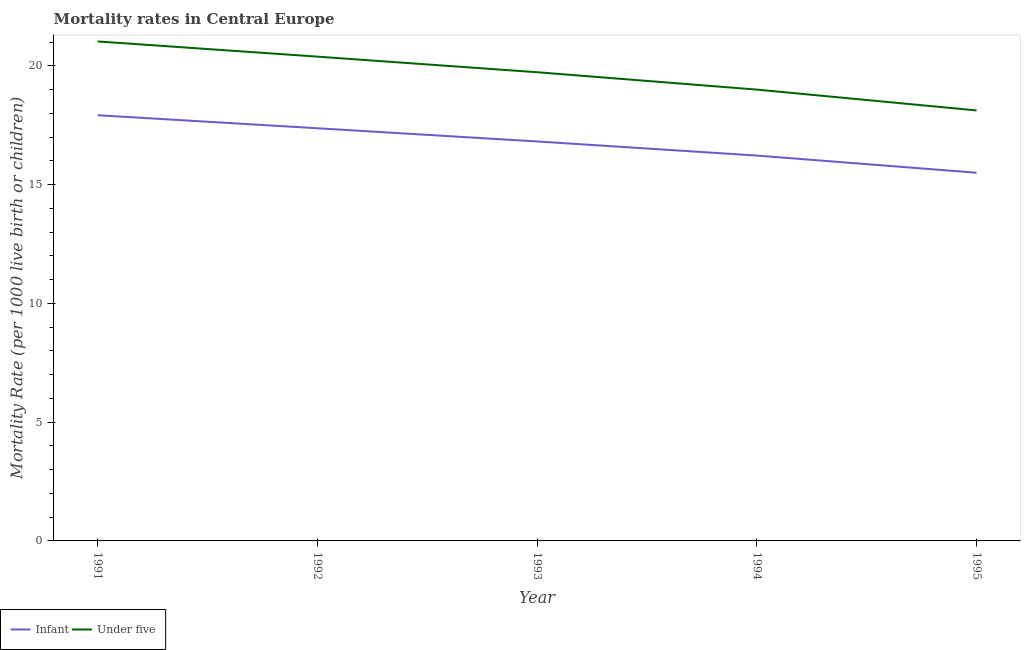Is the number of lines equal to the number of legend labels?
Provide a succinct answer. Yes. What is the infant mortality rate in 1991?
Provide a succinct answer. 17.92. Across all years, what is the maximum under-5 mortality rate?
Provide a succinct answer. 21.03. Across all years, what is the minimum under-5 mortality rate?
Ensure brevity in your answer.  18.13. In which year was the infant mortality rate minimum?
Offer a very short reply. 1995. What is the total infant mortality rate in the graph?
Your response must be concise. 83.85. What is the difference between the under-5 mortality rate in 1992 and that in 1994?
Your response must be concise. 1.39. What is the difference between the under-5 mortality rate in 1991 and the infant mortality rate in 1992?
Provide a succinct answer. 3.66. What is the average infant mortality rate per year?
Ensure brevity in your answer.  16.77. In the year 1993, what is the difference between the under-5 mortality rate and infant mortality rate?
Give a very brief answer. 2.91. What is the ratio of the infant mortality rate in 1994 to that in 1995?
Offer a very short reply. 1.05. What is the difference between the highest and the second highest under-5 mortality rate?
Make the answer very short. 0.64. What is the difference between the highest and the lowest infant mortality rate?
Make the answer very short. 2.42. Is the under-5 mortality rate strictly less than the infant mortality rate over the years?
Make the answer very short. No. How many years are there in the graph?
Offer a terse response. 5. Does the graph contain any zero values?
Keep it short and to the point. No. Does the graph contain grids?
Provide a short and direct response. No. Where does the legend appear in the graph?
Give a very brief answer. Bottom left. What is the title of the graph?
Offer a very short reply. Mortality rates in Central Europe. What is the label or title of the Y-axis?
Provide a succinct answer. Mortality Rate (per 1000 live birth or children). What is the Mortality Rate (per 1000 live birth or children) of Infant in 1991?
Provide a short and direct response. 17.92. What is the Mortality Rate (per 1000 live birth or children) of Under five in 1991?
Your response must be concise. 21.03. What is the Mortality Rate (per 1000 live birth or children) in Infant in 1992?
Provide a succinct answer. 17.38. What is the Mortality Rate (per 1000 live birth or children) of Under five in 1992?
Provide a short and direct response. 20.39. What is the Mortality Rate (per 1000 live birth or children) of Infant in 1993?
Keep it short and to the point. 16.82. What is the Mortality Rate (per 1000 live birth or children) of Under five in 1993?
Provide a short and direct response. 19.73. What is the Mortality Rate (per 1000 live birth or children) in Infant in 1994?
Give a very brief answer. 16.23. What is the Mortality Rate (per 1000 live birth or children) in Under five in 1994?
Offer a terse response. 19. What is the Mortality Rate (per 1000 live birth or children) of Infant in 1995?
Your answer should be compact. 15.5. What is the Mortality Rate (per 1000 live birth or children) in Under five in 1995?
Keep it short and to the point. 18.13. Across all years, what is the maximum Mortality Rate (per 1000 live birth or children) in Infant?
Provide a short and direct response. 17.92. Across all years, what is the maximum Mortality Rate (per 1000 live birth or children) of Under five?
Keep it short and to the point. 21.03. Across all years, what is the minimum Mortality Rate (per 1000 live birth or children) of Infant?
Give a very brief answer. 15.5. Across all years, what is the minimum Mortality Rate (per 1000 live birth or children) of Under five?
Keep it short and to the point. 18.13. What is the total Mortality Rate (per 1000 live birth or children) in Infant in the graph?
Your response must be concise. 83.85. What is the total Mortality Rate (per 1000 live birth or children) of Under five in the graph?
Make the answer very short. 98.29. What is the difference between the Mortality Rate (per 1000 live birth or children) of Infant in 1991 and that in 1992?
Your answer should be very brief. 0.55. What is the difference between the Mortality Rate (per 1000 live birth or children) of Under five in 1991 and that in 1992?
Keep it short and to the point. 0.64. What is the difference between the Mortality Rate (per 1000 live birth or children) in Infant in 1991 and that in 1993?
Provide a short and direct response. 1.1. What is the difference between the Mortality Rate (per 1000 live birth or children) of Under five in 1991 and that in 1993?
Give a very brief answer. 1.3. What is the difference between the Mortality Rate (per 1000 live birth or children) of Infant in 1991 and that in 1994?
Your answer should be compact. 1.7. What is the difference between the Mortality Rate (per 1000 live birth or children) of Under five in 1991 and that in 1994?
Provide a short and direct response. 2.03. What is the difference between the Mortality Rate (per 1000 live birth or children) in Infant in 1991 and that in 1995?
Your response must be concise. 2.42. What is the difference between the Mortality Rate (per 1000 live birth or children) in Under five in 1991 and that in 1995?
Keep it short and to the point. 2.9. What is the difference between the Mortality Rate (per 1000 live birth or children) of Infant in 1992 and that in 1993?
Make the answer very short. 0.56. What is the difference between the Mortality Rate (per 1000 live birth or children) in Under five in 1992 and that in 1993?
Provide a succinct answer. 0.66. What is the difference between the Mortality Rate (per 1000 live birth or children) in Infant in 1992 and that in 1994?
Provide a short and direct response. 1.15. What is the difference between the Mortality Rate (per 1000 live birth or children) in Under five in 1992 and that in 1994?
Make the answer very short. 1.39. What is the difference between the Mortality Rate (per 1000 live birth or children) of Infant in 1992 and that in 1995?
Keep it short and to the point. 1.87. What is the difference between the Mortality Rate (per 1000 live birth or children) in Under five in 1992 and that in 1995?
Your answer should be very brief. 2.27. What is the difference between the Mortality Rate (per 1000 live birth or children) in Infant in 1993 and that in 1994?
Your answer should be very brief. 0.59. What is the difference between the Mortality Rate (per 1000 live birth or children) of Under five in 1993 and that in 1994?
Provide a short and direct response. 0.73. What is the difference between the Mortality Rate (per 1000 live birth or children) in Infant in 1993 and that in 1995?
Your response must be concise. 1.32. What is the difference between the Mortality Rate (per 1000 live birth or children) of Under five in 1993 and that in 1995?
Ensure brevity in your answer.  1.61. What is the difference between the Mortality Rate (per 1000 live birth or children) in Infant in 1994 and that in 1995?
Your response must be concise. 0.72. What is the difference between the Mortality Rate (per 1000 live birth or children) in Under five in 1994 and that in 1995?
Provide a succinct answer. 0.88. What is the difference between the Mortality Rate (per 1000 live birth or children) of Infant in 1991 and the Mortality Rate (per 1000 live birth or children) of Under five in 1992?
Ensure brevity in your answer.  -2.47. What is the difference between the Mortality Rate (per 1000 live birth or children) of Infant in 1991 and the Mortality Rate (per 1000 live birth or children) of Under five in 1993?
Provide a short and direct response. -1.81. What is the difference between the Mortality Rate (per 1000 live birth or children) in Infant in 1991 and the Mortality Rate (per 1000 live birth or children) in Under five in 1994?
Your answer should be compact. -1.08. What is the difference between the Mortality Rate (per 1000 live birth or children) of Infant in 1991 and the Mortality Rate (per 1000 live birth or children) of Under five in 1995?
Your answer should be very brief. -0.2. What is the difference between the Mortality Rate (per 1000 live birth or children) of Infant in 1992 and the Mortality Rate (per 1000 live birth or children) of Under five in 1993?
Provide a succinct answer. -2.36. What is the difference between the Mortality Rate (per 1000 live birth or children) of Infant in 1992 and the Mortality Rate (per 1000 live birth or children) of Under five in 1994?
Make the answer very short. -1.63. What is the difference between the Mortality Rate (per 1000 live birth or children) of Infant in 1992 and the Mortality Rate (per 1000 live birth or children) of Under five in 1995?
Keep it short and to the point. -0.75. What is the difference between the Mortality Rate (per 1000 live birth or children) in Infant in 1993 and the Mortality Rate (per 1000 live birth or children) in Under five in 1994?
Your response must be concise. -2.18. What is the difference between the Mortality Rate (per 1000 live birth or children) of Infant in 1993 and the Mortality Rate (per 1000 live birth or children) of Under five in 1995?
Your answer should be compact. -1.31. What is the difference between the Mortality Rate (per 1000 live birth or children) of Infant in 1994 and the Mortality Rate (per 1000 live birth or children) of Under five in 1995?
Keep it short and to the point. -1.9. What is the average Mortality Rate (per 1000 live birth or children) of Infant per year?
Your answer should be very brief. 16.77. What is the average Mortality Rate (per 1000 live birth or children) of Under five per year?
Your answer should be very brief. 19.66. In the year 1991, what is the difference between the Mortality Rate (per 1000 live birth or children) in Infant and Mortality Rate (per 1000 live birth or children) in Under five?
Give a very brief answer. -3.11. In the year 1992, what is the difference between the Mortality Rate (per 1000 live birth or children) in Infant and Mortality Rate (per 1000 live birth or children) in Under five?
Your response must be concise. -3.02. In the year 1993, what is the difference between the Mortality Rate (per 1000 live birth or children) of Infant and Mortality Rate (per 1000 live birth or children) of Under five?
Provide a succinct answer. -2.91. In the year 1994, what is the difference between the Mortality Rate (per 1000 live birth or children) in Infant and Mortality Rate (per 1000 live birth or children) in Under five?
Provide a short and direct response. -2.78. In the year 1995, what is the difference between the Mortality Rate (per 1000 live birth or children) in Infant and Mortality Rate (per 1000 live birth or children) in Under five?
Provide a short and direct response. -2.62. What is the ratio of the Mortality Rate (per 1000 live birth or children) in Infant in 1991 to that in 1992?
Make the answer very short. 1.03. What is the ratio of the Mortality Rate (per 1000 live birth or children) in Under five in 1991 to that in 1992?
Offer a very short reply. 1.03. What is the ratio of the Mortality Rate (per 1000 live birth or children) of Infant in 1991 to that in 1993?
Your response must be concise. 1.07. What is the ratio of the Mortality Rate (per 1000 live birth or children) of Under five in 1991 to that in 1993?
Your answer should be very brief. 1.07. What is the ratio of the Mortality Rate (per 1000 live birth or children) in Infant in 1991 to that in 1994?
Your answer should be compact. 1.1. What is the ratio of the Mortality Rate (per 1000 live birth or children) of Under five in 1991 to that in 1994?
Make the answer very short. 1.11. What is the ratio of the Mortality Rate (per 1000 live birth or children) in Infant in 1991 to that in 1995?
Your answer should be very brief. 1.16. What is the ratio of the Mortality Rate (per 1000 live birth or children) of Under five in 1991 to that in 1995?
Provide a succinct answer. 1.16. What is the ratio of the Mortality Rate (per 1000 live birth or children) in Infant in 1992 to that in 1993?
Ensure brevity in your answer.  1.03. What is the ratio of the Mortality Rate (per 1000 live birth or children) of Under five in 1992 to that in 1993?
Ensure brevity in your answer.  1.03. What is the ratio of the Mortality Rate (per 1000 live birth or children) in Infant in 1992 to that in 1994?
Your answer should be compact. 1.07. What is the ratio of the Mortality Rate (per 1000 live birth or children) in Under five in 1992 to that in 1994?
Provide a short and direct response. 1.07. What is the ratio of the Mortality Rate (per 1000 live birth or children) in Infant in 1992 to that in 1995?
Your answer should be very brief. 1.12. What is the ratio of the Mortality Rate (per 1000 live birth or children) of Under five in 1992 to that in 1995?
Offer a terse response. 1.12. What is the ratio of the Mortality Rate (per 1000 live birth or children) in Infant in 1993 to that in 1994?
Provide a succinct answer. 1.04. What is the ratio of the Mortality Rate (per 1000 live birth or children) of Infant in 1993 to that in 1995?
Your answer should be compact. 1.08. What is the ratio of the Mortality Rate (per 1000 live birth or children) of Under five in 1993 to that in 1995?
Your answer should be very brief. 1.09. What is the ratio of the Mortality Rate (per 1000 live birth or children) in Infant in 1994 to that in 1995?
Provide a short and direct response. 1.05. What is the ratio of the Mortality Rate (per 1000 live birth or children) of Under five in 1994 to that in 1995?
Your answer should be compact. 1.05. What is the difference between the highest and the second highest Mortality Rate (per 1000 live birth or children) of Infant?
Make the answer very short. 0.55. What is the difference between the highest and the second highest Mortality Rate (per 1000 live birth or children) in Under five?
Provide a succinct answer. 0.64. What is the difference between the highest and the lowest Mortality Rate (per 1000 live birth or children) of Infant?
Keep it short and to the point. 2.42. What is the difference between the highest and the lowest Mortality Rate (per 1000 live birth or children) of Under five?
Provide a short and direct response. 2.9. 